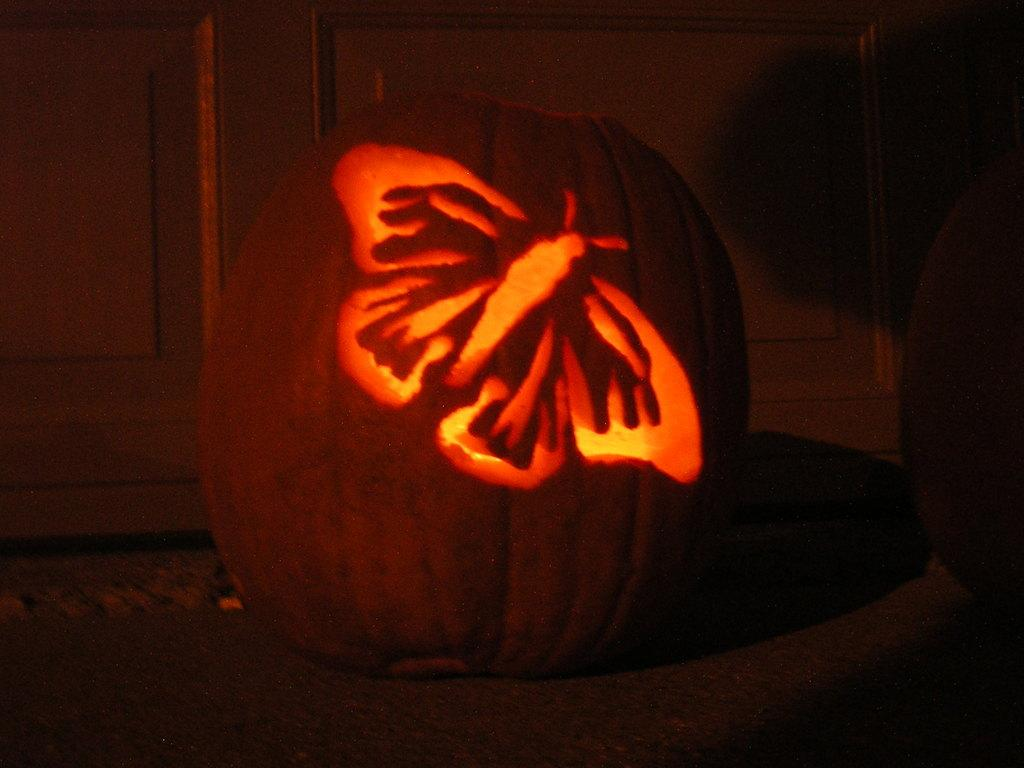What is the main subject of the image? The main subject of the image is a pumpkin. What is unique about the pumpkin? The pumpkin has a carving of a butterfly. How is the pumpkin illuminated? There is light inside the pumpkin. What can be seen in the background of the image? There is a wooden wall in the background of the image. What type of crime is being committed in the image? There is no crime being committed in the image; it features a carved pumpkin with light inside. Can you see a frog sitting on the pumpkin in the image? No, there is no frog present in the image. 